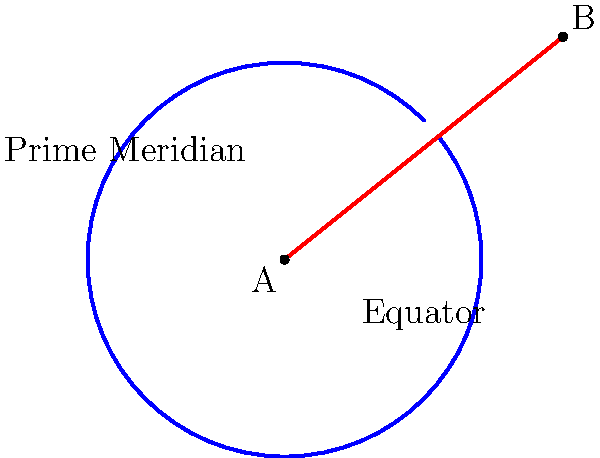As an experienced pilot, you understand the importance of efficient navigation. Consider a flight from point A to point B on a globe, as shown in the diagram. The blue curve represents the great circle route, while the red line represents the rhumb line. Which route would you choose for long-distance flights, and why? To answer this question, let's consider the key differences between great circle routes and rhumb lines:

1. Great Circle Route:
   - Shortest distance between two points on a sphere
   - Constantly changing bearing (direction)
   - Appears curved on a flat map projection
   - Follows the curvature of the Earth

2. Rhumb Line:
   - Constant bearing throughout the journey
   - Appears as a straight line on a Mercator projection
   - Generally longer distance than the great circle route
   - Easier to navigate without advanced instruments

For long-distance flights, the great circle route is preferred because:

a) It provides the shortest distance between two points, which results in:
   - Reduced flight time
   - Lower fuel consumption
   - Increased range capability

b) Modern navigation systems and GPS technology make it easy to follow great circle routes, eliminating the historical advantage of rhumb line's constant bearing.

c) The fuel savings on long-distance flights can be significant, often outweighing any minor navigational complexity.

d) Great circle routes take advantage of the Earth's curvature, which becomes more pronounced over longer distances.

However, it's worth noting that actual flight paths may deviate from perfect great circle routes due to:
- Air traffic control requirements
- Weather conditions
- Jet streams and winds
- Political airspace restrictions

In practice, long-distance flights often use a series of connected great circle segments to approximate the ideal great circle route while accommodating real-world constraints.
Answer: Great circle route; shortest distance, fuel-efficient for long flights. 